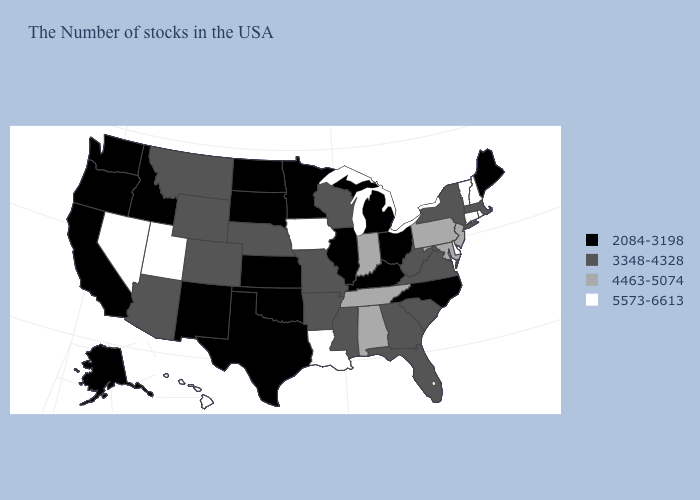What is the value of Maryland?
Concise answer only. 4463-5074. Does the first symbol in the legend represent the smallest category?
Be succinct. Yes. Is the legend a continuous bar?
Be succinct. No. Name the states that have a value in the range 5573-6613?
Short answer required. Rhode Island, New Hampshire, Vermont, Connecticut, Delaware, Louisiana, Iowa, Utah, Nevada, Hawaii. Which states hav the highest value in the Northeast?
Short answer required. Rhode Island, New Hampshire, Vermont, Connecticut. How many symbols are there in the legend?
Quick response, please. 4. Does Louisiana have the highest value in the South?
Be succinct. Yes. Name the states that have a value in the range 2084-3198?
Answer briefly. Maine, North Carolina, Ohio, Michigan, Kentucky, Illinois, Minnesota, Kansas, Oklahoma, Texas, South Dakota, North Dakota, New Mexico, Idaho, California, Washington, Oregon, Alaska. Does Oklahoma have the same value as Louisiana?
Concise answer only. No. What is the value of Texas?
Answer briefly. 2084-3198. Does Kansas have the highest value in the USA?
Write a very short answer. No. Is the legend a continuous bar?
Concise answer only. No. What is the highest value in the Northeast ?
Keep it brief. 5573-6613. What is the highest value in states that border North Dakota?
Short answer required. 3348-4328. What is the lowest value in the West?
Keep it brief. 2084-3198. 